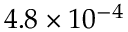Convert formula to latex. <formula><loc_0><loc_0><loc_500><loc_500>4 . 8 \times 1 0 ^ { - 4 }</formula> 